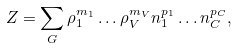Convert formula to latex. <formula><loc_0><loc_0><loc_500><loc_500>Z = \sum _ { G } \rho _ { 1 } ^ { m _ { 1 } } \dots \rho _ { V } ^ { m _ { V } } n _ { 1 } ^ { p _ { 1 } } \dots n _ { C } ^ { p _ { C } } ,</formula> 